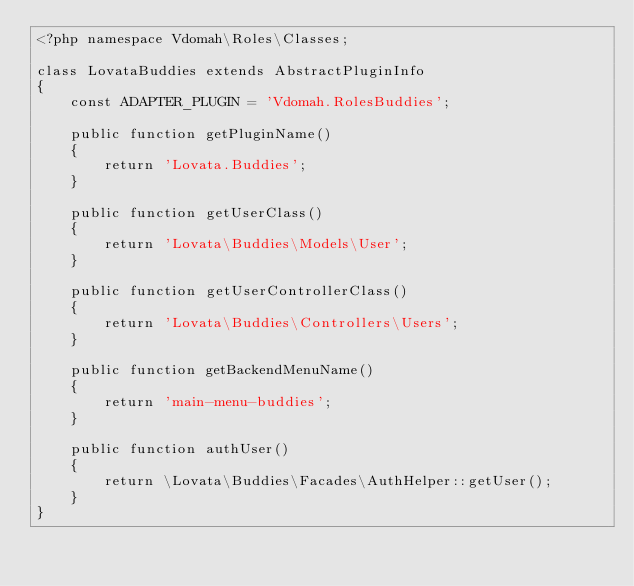<code> <loc_0><loc_0><loc_500><loc_500><_PHP_><?php namespace Vdomah\Roles\Classes;

class LovataBuddies extends AbstractPluginInfo
{
    const ADAPTER_PLUGIN = 'Vdomah.RolesBuddies';

    public function getPluginName()
    {
        return 'Lovata.Buddies';
    }

    public function getUserClass()
    {
        return 'Lovata\Buddies\Models\User';
    }

    public function getUserControllerClass()
    {
        return 'Lovata\Buddies\Controllers\Users';
    }

    public function getBackendMenuName()
    {
        return 'main-menu-buddies';
    }

    public function authUser()
    {
        return \Lovata\Buddies\Facades\AuthHelper::getUser();
    }
}</code> 